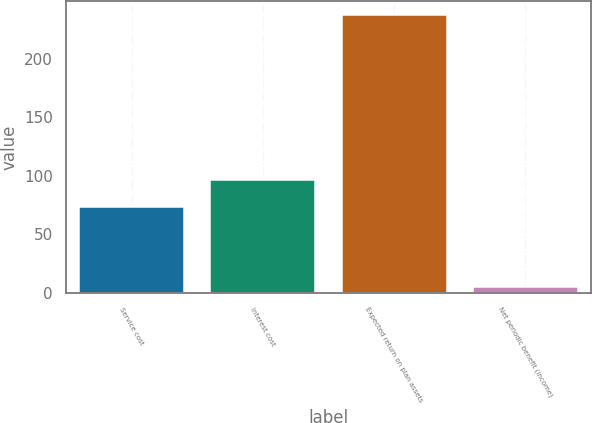Convert chart to OTSL. <chart><loc_0><loc_0><loc_500><loc_500><bar_chart><fcel>Service cost<fcel>Interest cost<fcel>Expected return on plan assets<fcel>Net periodic benefit (income)<nl><fcel>73<fcel>96.2<fcel>237<fcel>5<nl></chart> 